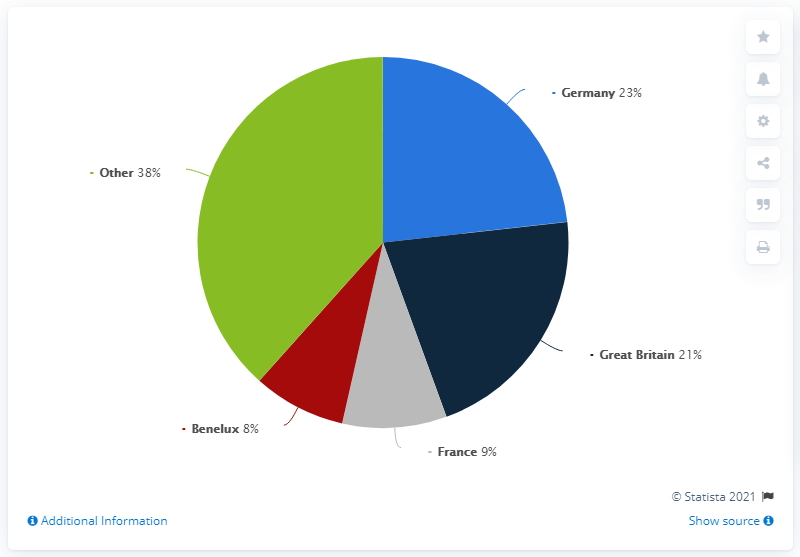Outline some significant characteristics in this image. In 2019, Germany was the country that generated 23 percent of Hugo Boss's total sales in Europe. The difference between the highest and lowest sales share of Hugo Boss in Europe in 2019, by country, was 15%. According to data from 2019, Hugo Boss had the largest sales share in Europe among all countries, with Germany having the largest share of sales. 